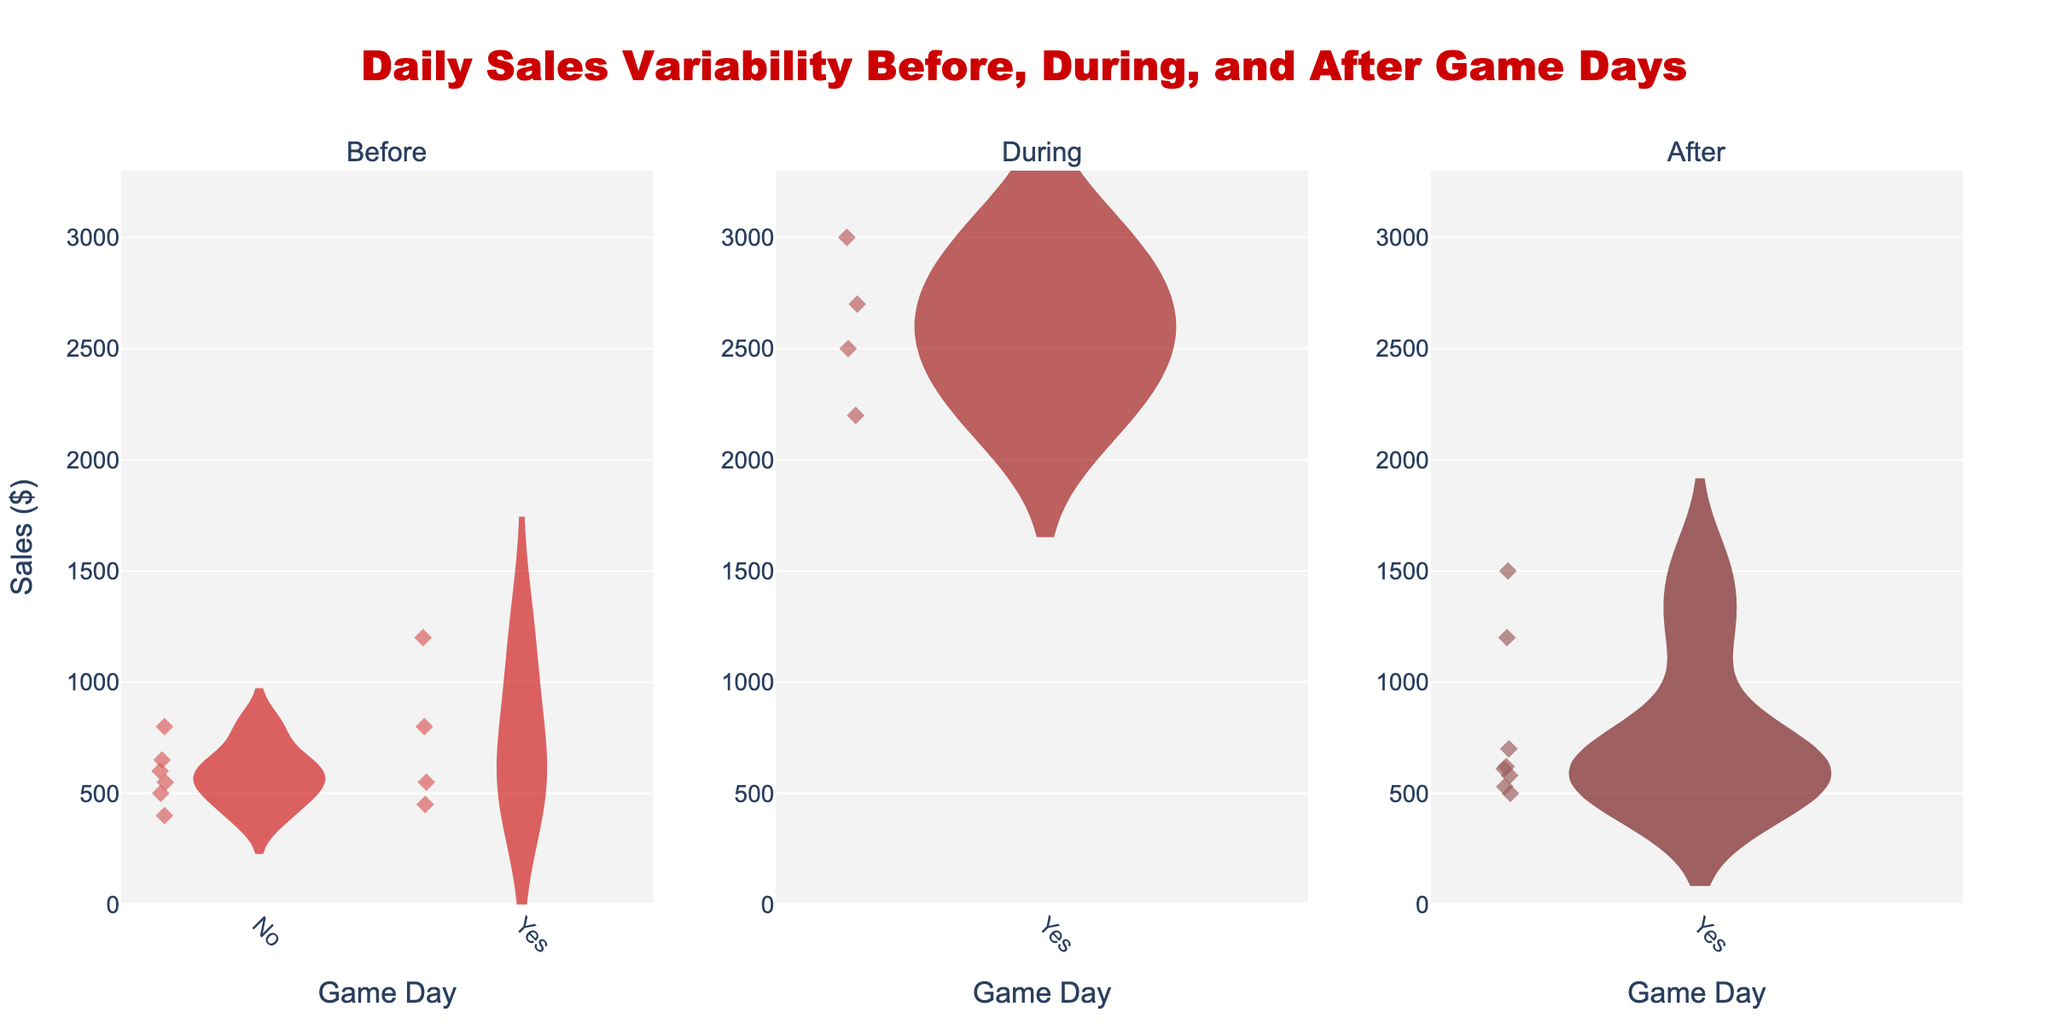What's the title of the figure? The title is located at the top center of the figure. It clearly states the purpose or focus of the chart.
Answer: Daily Sales Variability Before, During, and After Game Days How many subplots are there and what do they represent? Each violin chart represents a different period relative to the game days. Count the separate charts from left to right.
Answer: 3 subplots representing Before, During, and After game days What's the range of the y-axis for sales? The y-axis range is shown on the left-hand side of each violin chart, typically with tick marks indicating the extent.
Answer: 0 to 3300 (approximately) How does the sales variability during game days compare to before and after game days? Observe the width and spread of the violins, with wider sections indicating higher variability. Compare the ranges of values covered.
Answer: During game days show higher sales variability than before and after game days What is the median sales value during game days? Look for the horizontal line inside the violin plot for the "During" game days which represents the median (meanline).
Answer: 2600 (approximately) Which period has the highest peak in sales? Identify the highest point reached by the data within each period on the y-axis. Compare the peaks across all three periods.
Answer: During game days Are the sales more consistent before or after game days? Compare the width and shape of the penguins before and after game days. Wider spreads suggest more variability.
Answer: After game days How many game days are depicted in the plot? Count how many data points are marked as "Yes" under each subplot across all periods. Each point represents a game day.
Answer: 2 game days How do sales on non-game days before the game compare to sales on non-game days after the game? Compare the spread and central tendency of sales for non-game days under the "Before" and "After" categories.
Answer: Sales on non-game days before the game are slightly higher than sales on non-game days after the game What is the mean sales value for the period after game days? Observing the violin plot for the "After" game days, look for the marked mean line, typically a horizontal bar or line.
Answer: 570 (approximately) 